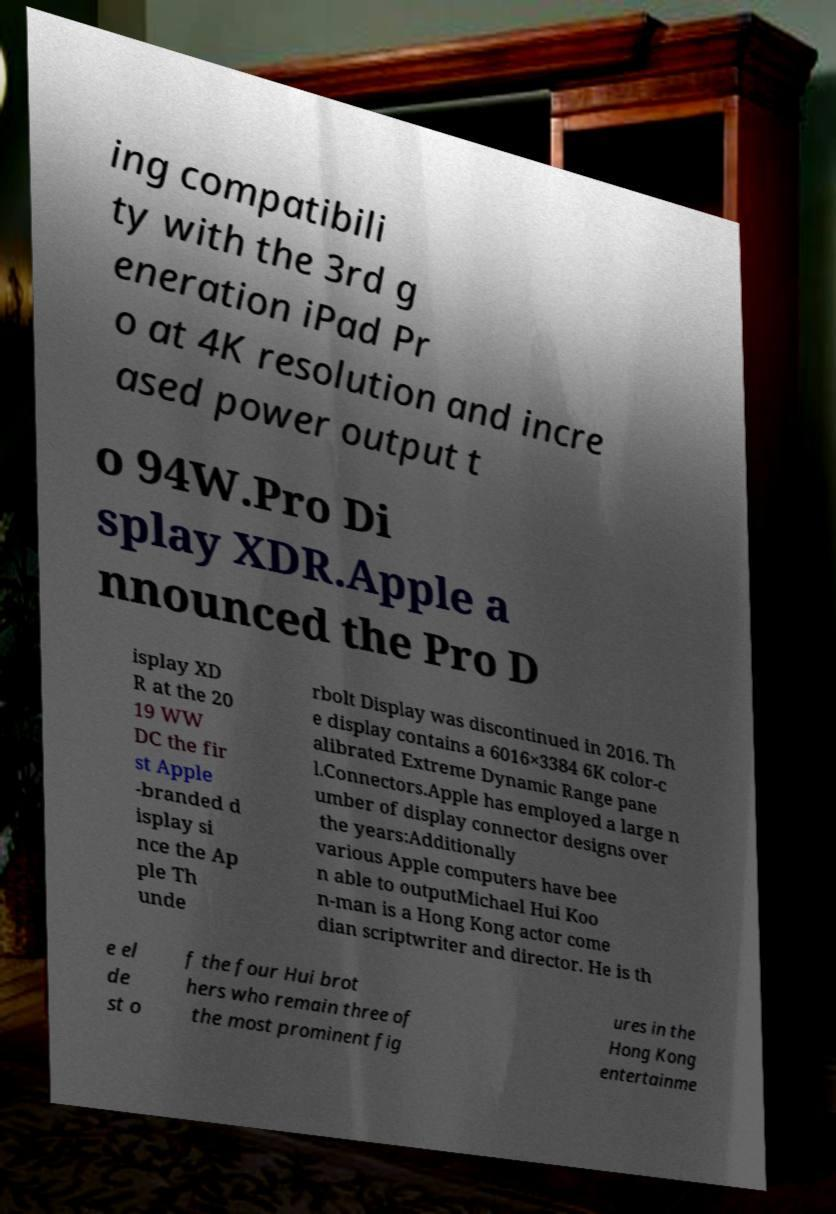Could you extract and type out the text from this image? ing compatibili ty with the 3rd g eneration iPad Pr o at 4K resolution and incre ased power output t o 94W.Pro Di splay XDR.Apple a nnounced the Pro D isplay XD R at the 20 19 WW DC the fir st Apple -branded d isplay si nce the Ap ple Th unde rbolt Display was discontinued in 2016. Th e display contains a 6016×3384 6K color-c alibrated Extreme Dynamic Range pane l.Connectors.Apple has employed a large n umber of display connector designs over the years:Additionally various Apple computers have bee n able to outputMichael Hui Koo n-man is a Hong Kong actor come dian scriptwriter and director. He is th e el de st o f the four Hui brot hers who remain three of the most prominent fig ures in the Hong Kong entertainme 